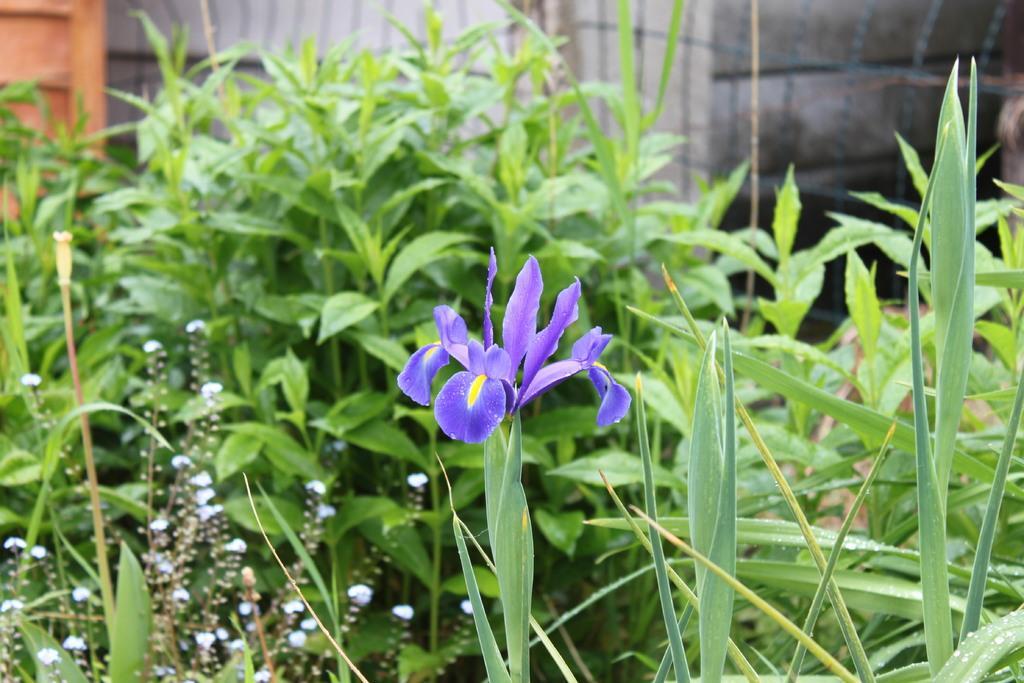In one or two sentences, can you explain what this image depicts? In the front of the image i can see plants and flowers. In the background of the image there is a mesh, wooden object and wall.   